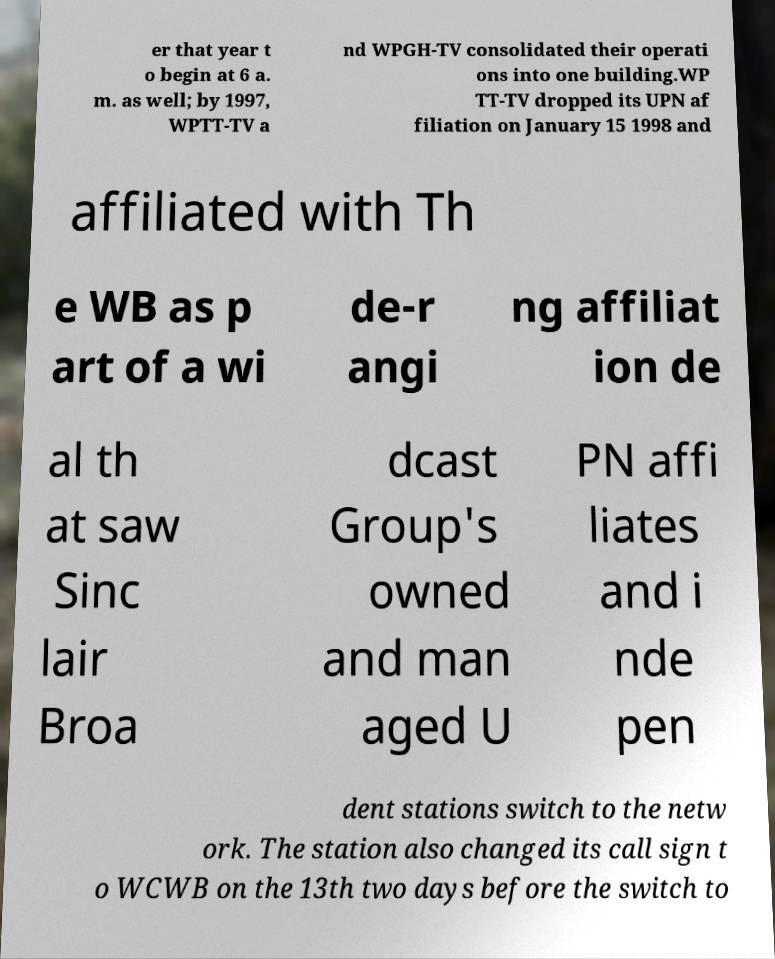Please read and relay the text visible in this image. What does it say? er that year t o begin at 6 a. m. as well; by 1997, WPTT-TV a nd WPGH-TV consolidated their operati ons into one building.WP TT-TV dropped its UPN af filiation on January 15 1998 and affiliated with Th e WB as p art of a wi de-r angi ng affiliat ion de al th at saw Sinc lair Broa dcast Group's owned and man aged U PN affi liates and i nde pen dent stations switch to the netw ork. The station also changed its call sign t o WCWB on the 13th two days before the switch to 